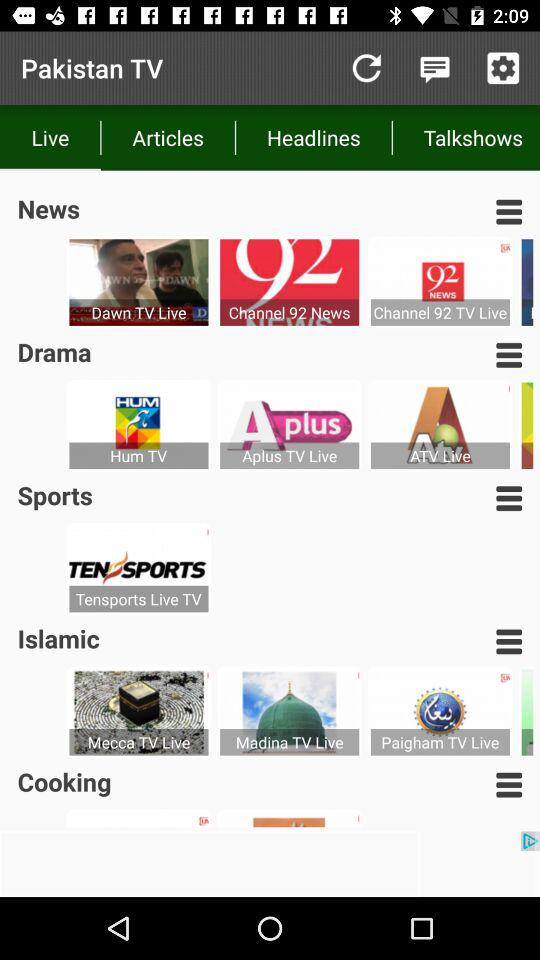What type of channel is "Dawn TV"? "Dawn TV" is a news channel. 